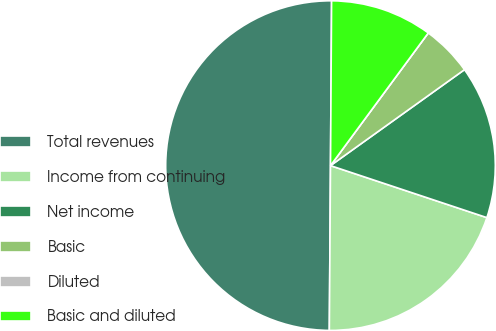Convert chart. <chart><loc_0><loc_0><loc_500><loc_500><pie_chart><fcel>Total revenues<fcel>Income from continuing<fcel>Net income<fcel>Basic<fcel>Diluted<fcel>Basic and diluted<nl><fcel>49.99%<fcel>20.0%<fcel>15.0%<fcel>5.0%<fcel>0.0%<fcel>10.0%<nl></chart> 